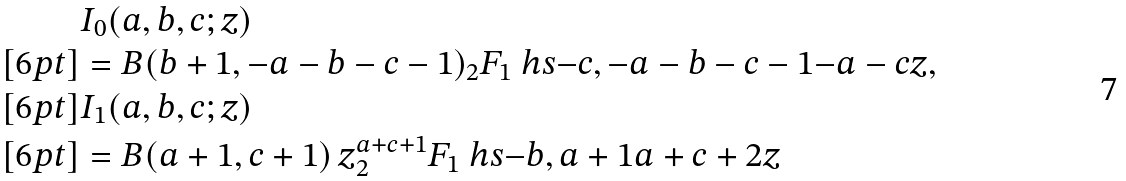Convert formula to latex. <formula><loc_0><loc_0><loc_500><loc_500>& I _ { 0 } ( a , b , c ; z ) \\ [ 6 p t ] & = B ( b + 1 , - a - b - c - 1 ) _ { 2 } F _ { 1 } \ h s { - c , - a - b - c - 1 } { - a - c } { z } , \\ [ 6 p t ] & I _ { 1 } ( a , b , c ; z ) \\ [ 6 p t ] & = B ( a + 1 , c + 1 ) \, z ^ { a + c + 1 } _ { 2 } F _ { 1 } \ h s { - b , a + 1 } { a + c + 2 } { z }</formula> 